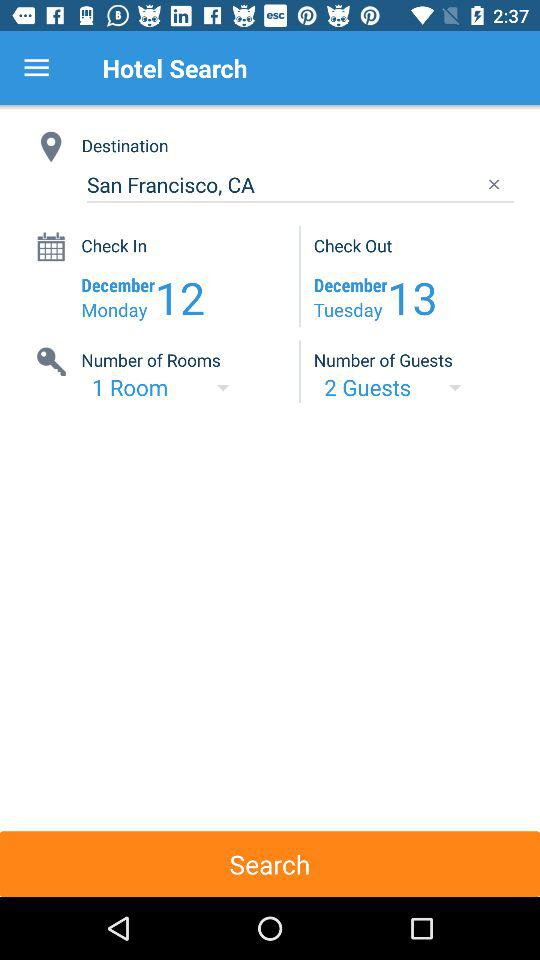What is the number of rooms? The number of rooms is 1. 